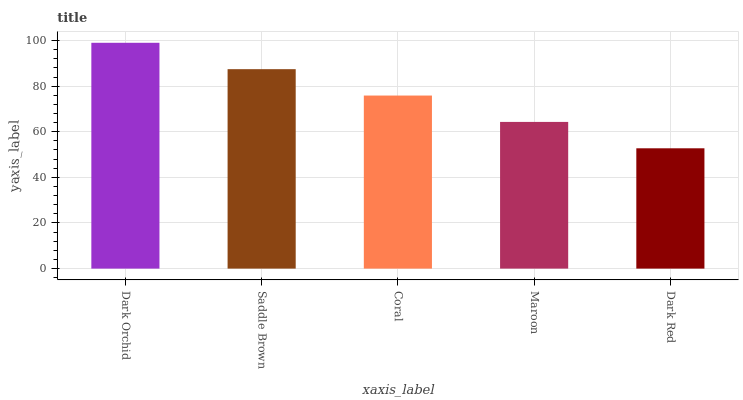Is Dark Red the minimum?
Answer yes or no. Yes. Is Dark Orchid the maximum?
Answer yes or no. Yes. Is Saddle Brown the minimum?
Answer yes or no. No. Is Saddle Brown the maximum?
Answer yes or no. No. Is Dark Orchid greater than Saddle Brown?
Answer yes or no. Yes. Is Saddle Brown less than Dark Orchid?
Answer yes or no. Yes. Is Saddle Brown greater than Dark Orchid?
Answer yes or no. No. Is Dark Orchid less than Saddle Brown?
Answer yes or no. No. Is Coral the high median?
Answer yes or no. Yes. Is Coral the low median?
Answer yes or no. Yes. Is Dark Red the high median?
Answer yes or no. No. Is Maroon the low median?
Answer yes or no. No. 